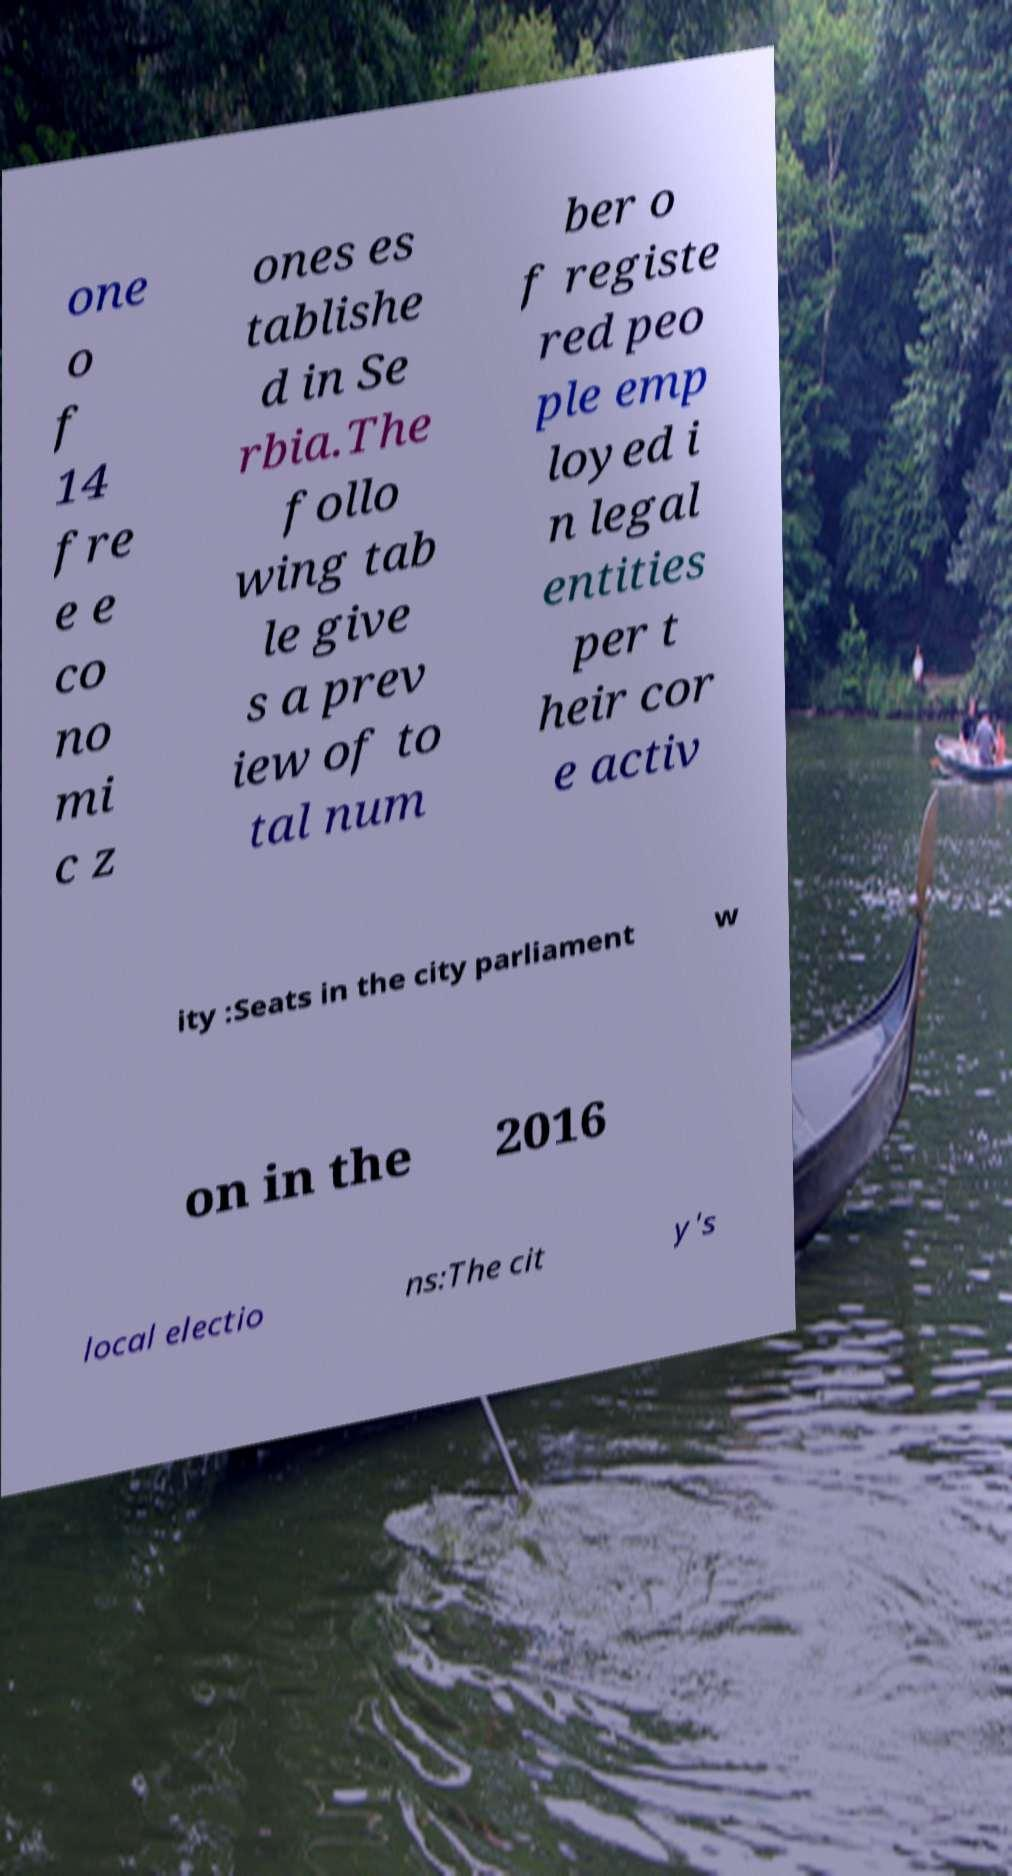Can you accurately transcribe the text from the provided image for me? one o f 14 fre e e co no mi c z ones es tablishe d in Se rbia.The follo wing tab le give s a prev iew of to tal num ber o f registe red peo ple emp loyed i n legal entities per t heir cor e activ ity :Seats in the city parliament w on in the 2016 local electio ns:The cit y's 